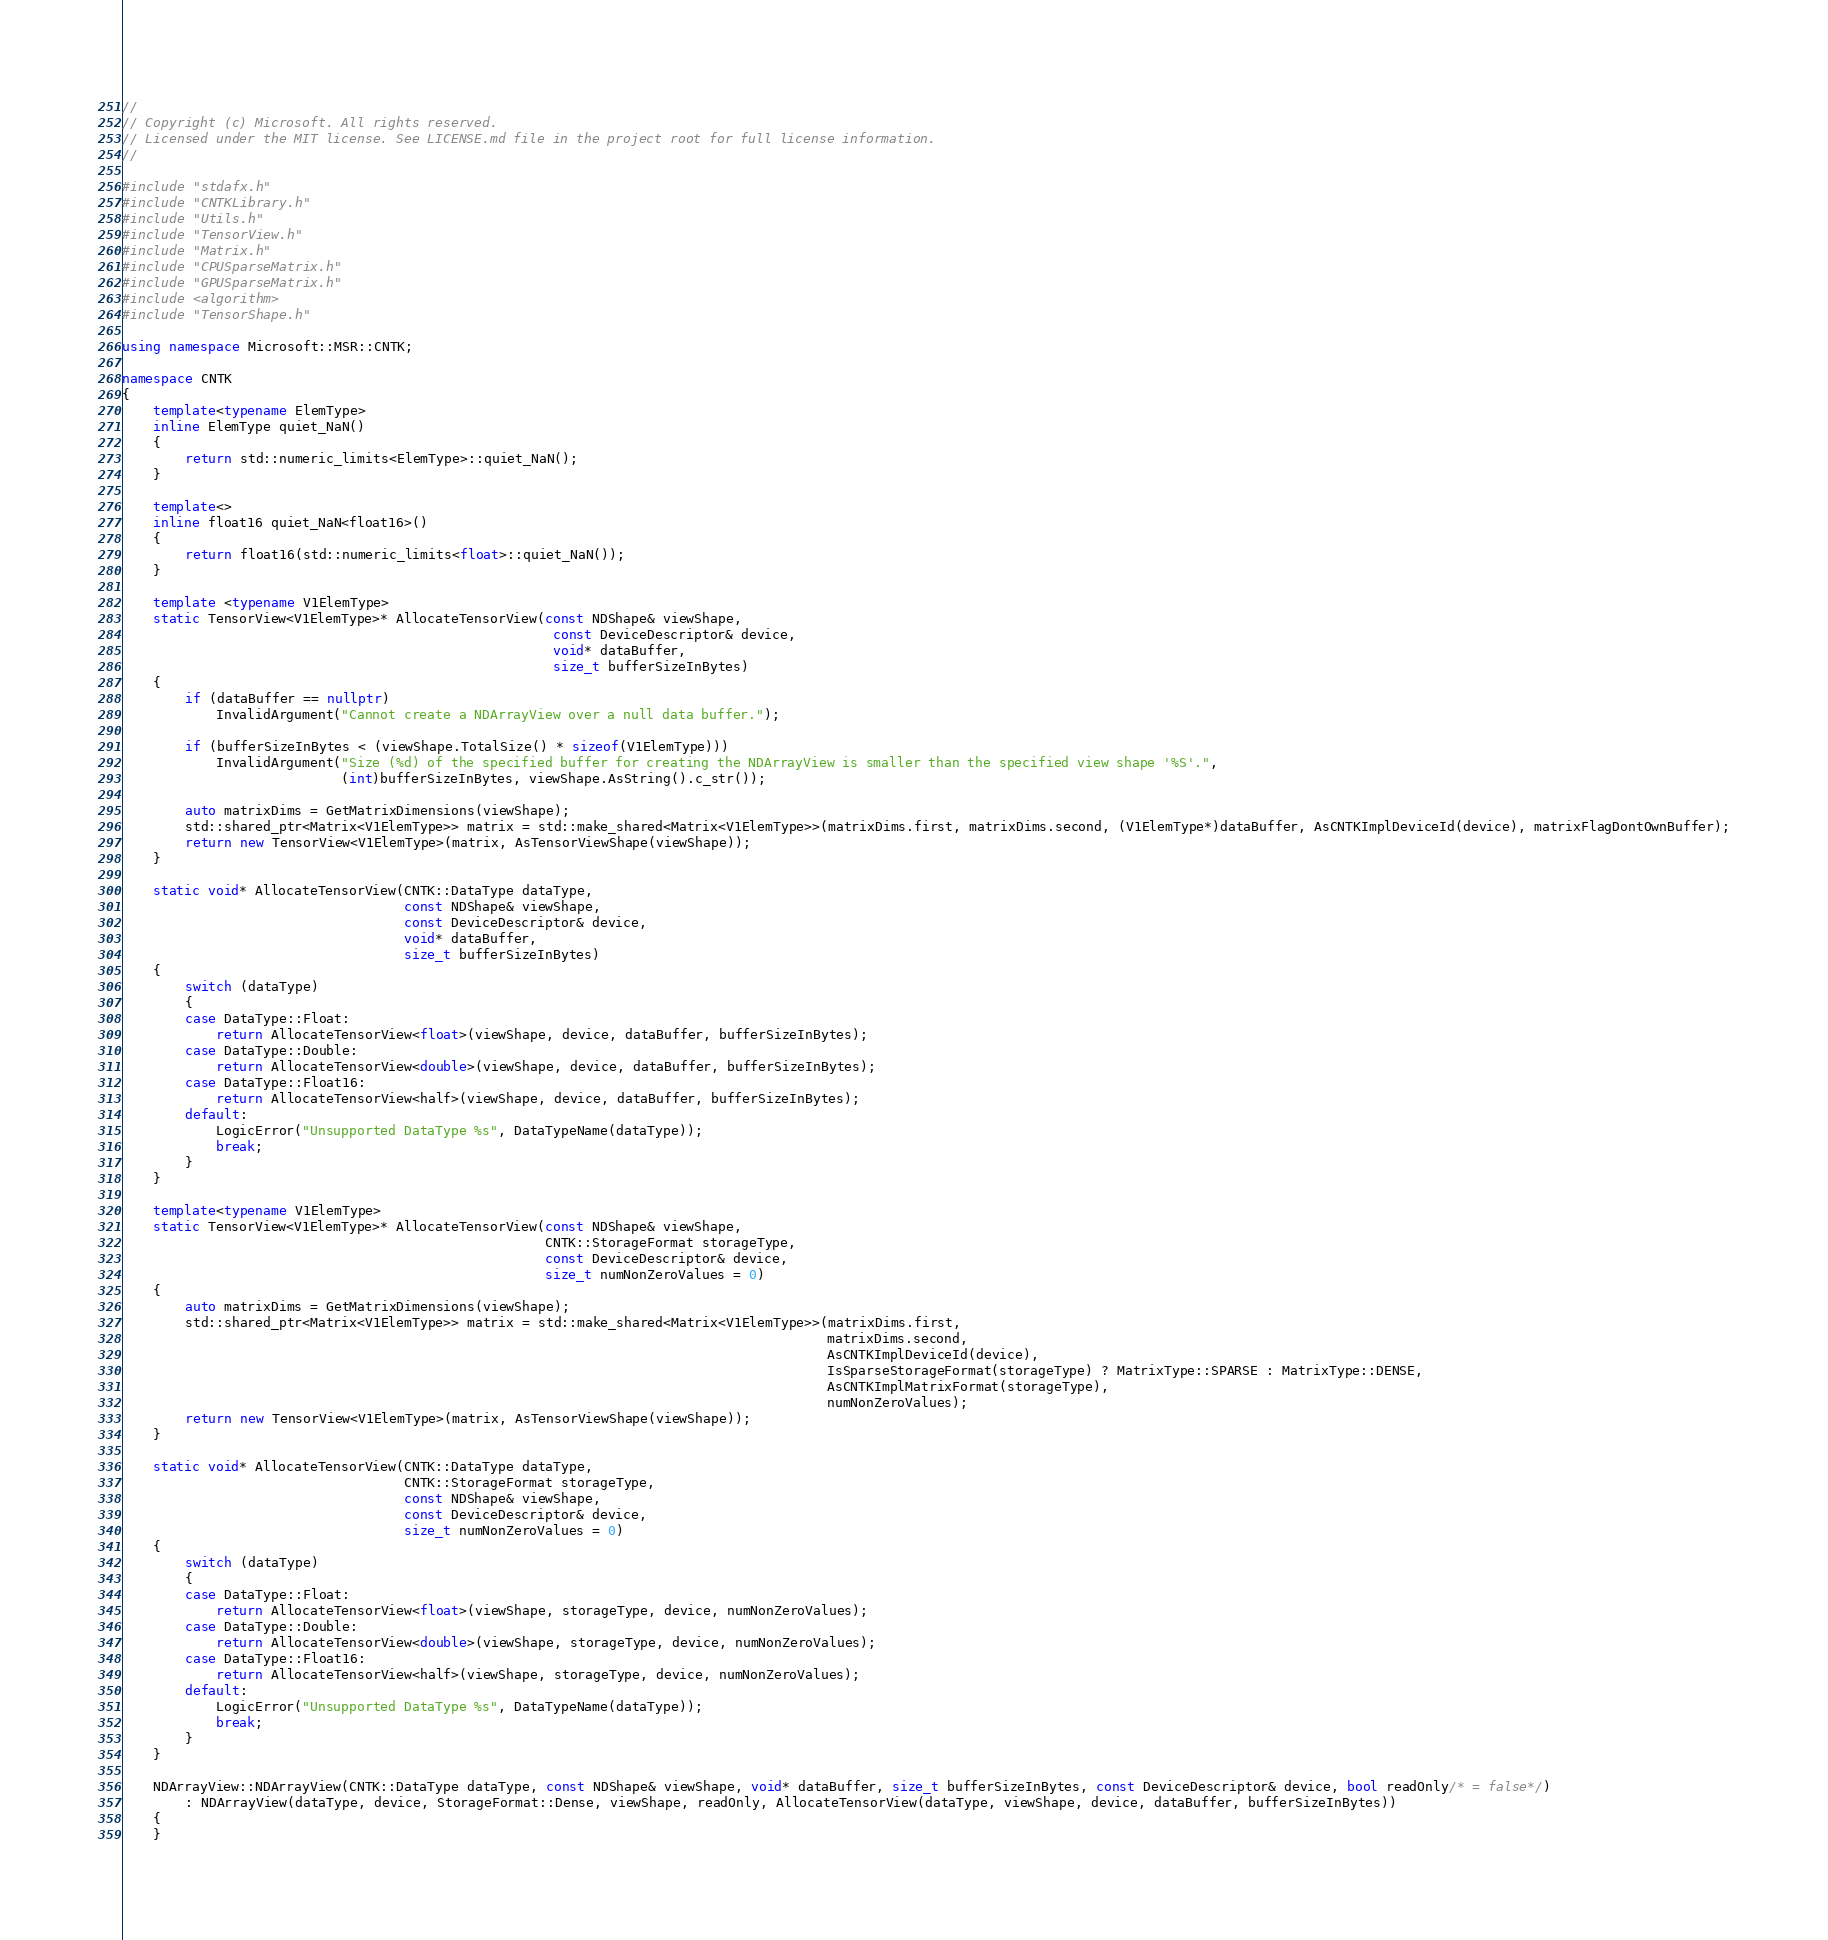<code> <loc_0><loc_0><loc_500><loc_500><_C++_>//
// Copyright (c) Microsoft. All rights reserved.
// Licensed under the MIT license. See LICENSE.md file in the project root for full license information.
//

#include "stdafx.h"
#include "CNTKLibrary.h"
#include "Utils.h"
#include "TensorView.h"
#include "Matrix.h"
#include "CPUSparseMatrix.h"
#include "GPUSparseMatrix.h"
#include <algorithm>
#include "TensorShape.h"

using namespace Microsoft::MSR::CNTK;

namespace CNTK
{
    template<typename ElemType>
    inline ElemType quiet_NaN()
    {
        return std::numeric_limits<ElemType>::quiet_NaN();
    }

    template<>
    inline float16 quiet_NaN<float16>()
    {
        return float16(std::numeric_limits<float>::quiet_NaN());
    }

    template <typename V1ElemType>
    static TensorView<V1ElemType>* AllocateTensorView(const NDShape& viewShape,
                                                       const DeviceDescriptor& device,
                                                       void* dataBuffer,
                                                       size_t bufferSizeInBytes)
    {
        if (dataBuffer == nullptr)
            InvalidArgument("Cannot create a NDArrayView over a null data buffer.");

        if (bufferSizeInBytes < (viewShape.TotalSize() * sizeof(V1ElemType)))
            InvalidArgument("Size (%d) of the specified buffer for creating the NDArrayView is smaller than the specified view shape '%S'.",
                            (int)bufferSizeInBytes, viewShape.AsString().c_str());

        auto matrixDims = GetMatrixDimensions(viewShape);
        std::shared_ptr<Matrix<V1ElemType>> matrix = std::make_shared<Matrix<V1ElemType>>(matrixDims.first, matrixDims.second, (V1ElemType*)dataBuffer, AsCNTKImplDeviceId(device), matrixFlagDontOwnBuffer);
        return new TensorView<V1ElemType>(matrix, AsTensorViewShape(viewShape));
    }

    static void* AllocateTensorView(CNTK::DataType dataType,
                                    const NDShape& viewShape,
                                    const DeviceDescriptor& device,
                                    void* dataBuffer,
                                    size_t bufferSizeInBytes)
    {
        switch (dataType)
        {
        case DataType::Float:
            return AllocateTensorView<float>(viewShape, device, dataBuffer, bufferSizeInBytes);
        case DataType::Double:
            return AllocateTensorView<double>(viewShape, device, dataBuffer, bufferSizeInBytes);
        case DataType::Float16:
            return AllocateTensorView<half>(viewShape, device, dataBuffer, bufferSizeInBytes);
        default:
            LogicError("Unsupported DataType %s", DataTypeName(dataType));
            break;
        }
    }

    template<typename V1ElemType>
    static TensorView<V1ElemType>* AllocateTensorView(const NDShape& viewShape,
                                                      CNTK::StorageFormat storageType,
                                                      const DeviceDescriptor& device,
                                                      size_t numNonZeroValues = 0)
    {
        auto matrixDims = GetMatrixDimensions(viewShape);
        std::shared_ptr<Matrix<V1ElemType>> matrix = std::make_shared<Matrix<V1ElemType>>(matrixDims.first,
                                                                                          matrixDims.second,
                                                                                          AsCNTKImplDeviceId(device),
                                                                                          IsSparseStorageFormat(storageType) ? MatrixType::SPARSE : MatrixType::DENSE,
                                                                                          AsCNTKImplMatrixFormat(storageType),
                                                                                          numNonZeroValues);
        return new TensorView<V1ElemType>(matrix, AsTensorViewShape(viewShape));
    }

    static void* AllocateTensorView(CNTK::DataType dataType,
                                    CNTK::StorageFormat storageType,
                                    const NDShape& viewShape,
                                    const DeviceDescriptor& device,
                                    size_t numNonZeroValues = 0)
    {
        switch (dataType)
        {
        case DataType::Float:
            return AllocateTensorView<float>(viewShape, storageType, device, numNonZeroValues);
        case DataType::Double:
            return AllocateTensorView<double>(viewShape, storageType, device, numNonZeroValues);
        case DataType::Float16:
            return AllocateTensorView<half>(viewShape, storageType, device, numNonZeroValues);
        default:
            LogicError("Unsupported DataType %s", DataTypeName(dataType));
            break;
        }
    }

    NDArrayView::NDArrayView(CNTK::DataType dataType, const NDShape& viewShape, void* dataBuffer, size_t bufferSizeInBytes, const DeviceDescriptor& device, bool readOnly/* = false*/)
        : NDArrayView(dataType, device, StorageFormat::Dense, viewShape, readOnly, AllocateTensorView(dataType, viewShape, device, dataBuffer, bufferSizeInBytes))
    {
    }
</code> 